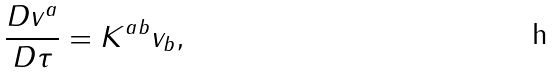<formula> <loc_0><loc_0><loc_500><loc_500>\frac { D v ^ { a } } { D \tau } = K ^ { a b } v _ { b } ,</formula> 